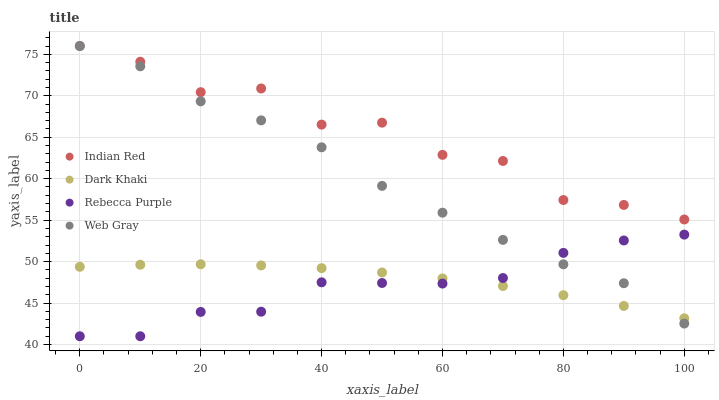Does Rebecca Purple have the minimum area under the curve?
Answer yes or no. Yes. Does Indian Red have the maximum area under the curve?
Answer yes or no. Yes. Does Web Gray have the minimum area under the curve?
Answer yes or no. No. Does Web Gray have the maximum area under the curve?
Answer yes or no. No. Is Dark Khaki the smoothest?
Answer yes or no. Yes. Is Indian Red the roughest?
Answer yes or no. Yes. Is Web Gray the smoothest?
Answer yes or no. No. Is Web Gray the roughest?
Answer yes or no. No. Does Rebecca Purple have the lowest value?
Answer yes or no. Yes. Does Web Gray have the lowest value?
Answer yes or no. No. Does Indian Red have the highest value?
Answer yes or no. Yes. Does Rebecca Purple have the highest value?
Answer yes or no. No. Is Dark Khaki less than Indian Red?
Answer yes or no. Yes. Is Indian Red greater than Rebecca Purple?
Answer yes or no. Yes. Does Dark Khaki intersect Rebecca Purple?
Answer yes or no. Yes. Is Dark Khaki less than Rebecca Purple?
Answer yes or no. No. Is Dark Khaki greater than Rebecca Purple?
Answer yes or no. No. Does Dark Khaki intersect Indian Red?
Answer yes or no. No. 